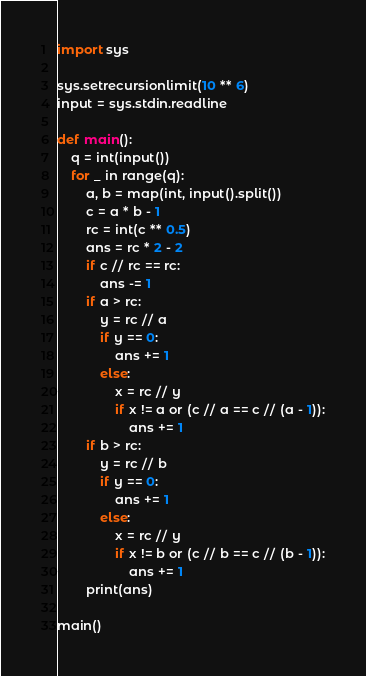<code> <loc_0><loc_0><loc_500><loc_500><_Python_>import sys

sys.setrecursionlimit(10 ** 6)
input = sys.stdin.readline

def main():
    q = int(input())
    for _ in range(q):
        a, b = map(int, input().split())
        c = a * b - 1
        rc = int(c ** 0.5)
        ans = rc * 2 - 2
        if c // rc == rc:
            ans -= 1
        if a > rc:
            y = rc // a
            if y == 0:
                ans += 1
            else:
                x = rc // y
                if x != a or (c // a == c // (a - 1)):
                    ans += 1
        if b > rc:
            y = rc // b
            if y == 0:
                ans += 1
            else:
                x = rc // y
                if x != b or (c // b == c // (b - 1)):
                    ans += 1
        print(ans)

main()
</code> 